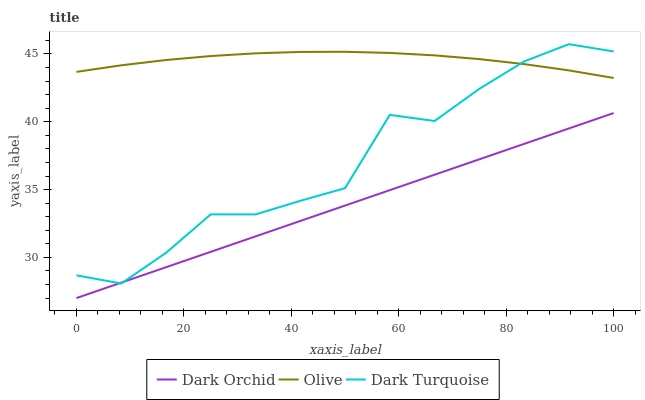Does Dark Turquoise have the minimum area under the curve?
Answer yes or no. No. Does Dark Turquoise have the maximum area under the curve?
Answer yes or no. No. Is Dark Turquoise the smoothest?
Answer yes or no. No. Is Dark Orchid the roughest?
Answer yes or no. No. Does Dark Turquoise have the lowest value?
Answer yes or no. No. Does Dark Orchid have the highest value?
Answer yes or no. No. Is Dark Orchid less than Olive?
Answer yes or no. Yes. Is Olive greater than Dark Orchid?
Answer yes or no. Yes. Does Dark Orchid intersect Olive?
Answer yes or no. No. 